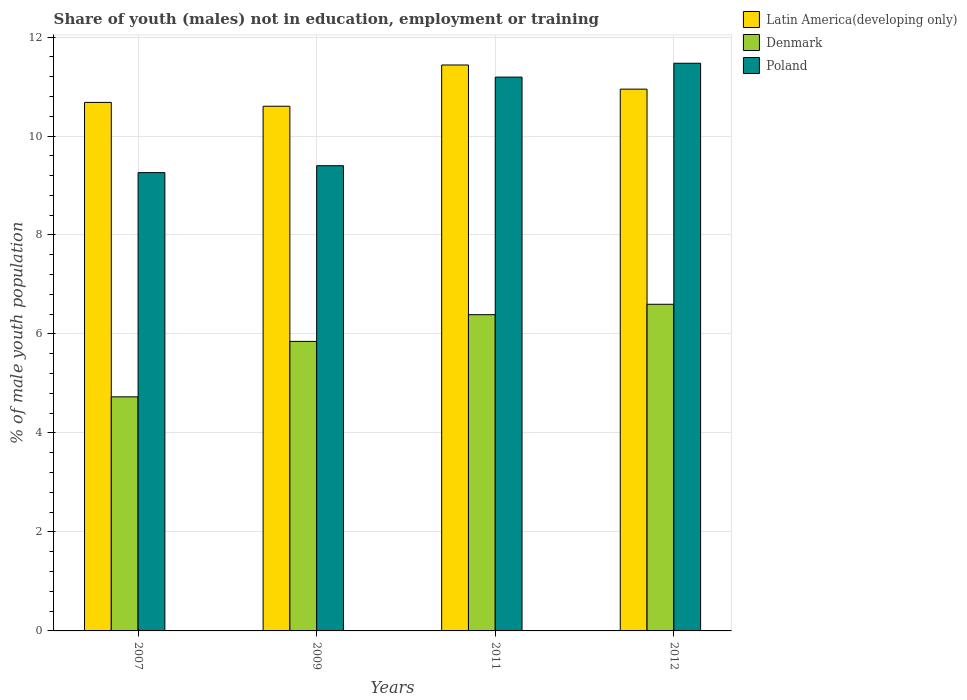How many different coloured bars are there?
Your response must be concise. 3. How many groups of bars are there?
Offer a very short reply. 4. Are the number of bars per tick equal to the number of legend labels?
Give a very brief answer. Yes. Are the number of bars on each tick of the X-axis equal?
Offer a very short reply. Yes. How many bars are there on the 3rd tick from the left?
Your answer should be very brief. 3. How many bars are there on the 4th tick from the right?
Your answer should be very brief. 3. What is the label of the 4th group of bars from the left?
Make the answer very short. 2012. What is the percentage of unemployed males population in in Latin America(developing only) in 2007?
Provide a succinct answer. 10.68. Across all years, what is the maximum percentage of unemployed males population in in Poland?
Your answer should be compact. 11.47. Across all years, what is the minimum percentage of unemployed males population in in Denmark?
Provide a short and direct response. 4.73. In which year was the percentage of unemployed males population in in Latin America(developing only) maximum?
Your response must be concise. 2011. In which year was the percentage of unemployed males population in in Denmark minimum?
Offer a very short reply. 2007. What is the total percentage of unemployed males population in in Denmark in the graph?
Keep it short and to the point. 23.57. What is the difference between the percentage of unemployed males population in in Latin America(developing only) in 2011 and that in 2012?
Offer a very short reply. 0.49. What is the difference between the percentage of unemployed males population in in Denmark in 2011 and the percentage of unemployed males population in in Latin America(developing only) in 2009?
Your answer should be compact. -4.21. What is the average percentage of unemployed males population in in Poland per year?
Your answer should be very brief. 10.33. In the year 2009, what is the difference between the percentage of unemployed males population in in Denmark and percentage of unemployed males population in in Poland?
Your response must be concise. -3.55. In how many years, is the percentage of unemployed males population in in Denmark greater than 10.4 %?
Give a very brief answer. 0. What is the ratio of the percentage of unemployed males population in in Poland in 2009 to that in 2012?
Your answer should be compact. 0.82. Is the difference between the percentage of unemployed males population in in Denmark in 2011 and 2012 greater than the difference between the percentage of unemployed males population in in Poland in 2011 and 2012?
Make the answer very short. Yes. What is the difference between the highest and the second highest percentage of unemployed males population in in Poland?
Your answer should be compact. 0.28. What is the difference between the highest and the lowest percentage of unemployed males population in in Latin America(developing only)?
Provide a succinct answer. 0.83. Is the sum of the percentage of unemployed males population in in Latin America(developing only) in 2011 and 2012 greater than the maximum percentage of unemployed males population in in Poland across all years?
Provide a short and direct response. Yes. What does the 3rd bar from the left in 2009 represents?
Provide a succinct answer. Poland. What does the 3rd bar from the right in 2007 represents?
Offer a very short reply. Latin America(developing only). How many bars are there?
Offer a very short reply. 12. How many years are there in the graph?
Provide a succinct answer. 4. How many legend labels are there?
Provide a short and direct response. 3. What is the title of the graph?
Your answer should be very brief. Share of youth (males) not in education, employment or training. Does "Uruguay" appear as one of the legend labels in the graph?
Your answer should be very brief. No. What is the label or title of the Y-axis?
Make the answer very short. % of male youth population. What is the % of male youth population in Latin America(developing only) in 2007?
Offer a terse response. 10.68. What is the % of male youth population in Denmark in 2007?
Your response must be concise. 4.73. What is the % of male youth population in Poland in 2007?
Keep it short and to the point. 9.26. What is the % of male youth population in Latin America(developing only) in 2009?
Your answer should be compact. 10.6. What is the % of male youth population of Denmark in 2009?
Keep it short and to the point. 5.85. What is the % of male youth population of Poland in 2009?
Your response must be concise. 9.4. What is the % of male youth population in Latin America(developing only) in 2011?
Make the answer very short. 11.43. What is the % of male youth population of Denmark in 2011?
Make the answer very short. 6.39. What is the % of male youth population of Poland in 2011?
Offer a terse response. 11.19. What is the % of male youth population in Latin America(developing only) in 2012?
Your answer should be very brief. 10.95. What is the % of male youth population in Denmark in 2012?
Your answer should be very brief. 6.6. What is the % of male youth population of Poland in 2012?
Offer a terse response. 11.47. Across all years, what is the maximum % of male youth population of Latin America(developing only)?
Keep it short and to the point. 11.43. Across all years, what is the maximum % of male youth population of Denmark?
Make the answer very short. 6.6. Across all years, what is the maximum % of male youth population in Poland?
Your answer should be compact. 11.47. Across all years, what is the minimum % of male youth population in Latin America(developing only)?
Your answer should be compact. 10.6. Across all years, what is the minimum % of male youth population of Denmark?
Provide a succinct answer. 4.73. Across all years, what is the minimum % of male youth population in Poland?
Provide a short and direct response. 9.26. What is the total % of male youth population in Latin America(developing only) in the graph?
Give a very brief answer. 43.66. What is the total % of male youth population in Denmark in the graph?
Give a very brief answer. 23.57. What is the total % of male youth population of Poland in the graph?
Your answer should be very brief. 41.32. What is the difference between the % of male youth population of Latin America(developing only) in 2007 and that in 2009?
Offer a very short reply. 0.08. What is the difference between the % of male youth population in Denmark in 2007 and that in 2009?
Provide a succinct answer. -1.12. What is the difference between the % of male youth population of Poland in 2007 and that in 2009?
Make the answer very short. -0.14. What is the difference between the % of male youth population of Latin America(developing only) in 2007 and that in 2011?
Provide a succinct answer. -0.76. What is the difference between the % of male youth population of Denmark in 2007 and that in 2011?
Your answer should be compact. -1.66. What is the difference between the % of male youth population in Poland in 2007 and that in 2011?
Keep it short and to the point. -1.93. What is the difference between the % of male youth population in Latin America(developing only) in 2007 and that in 2012?
Keep it short and to the point. -0.27. What is the difference between the % of male youth population of Denmark in 2007 and that in 2012?
Offer a terse response. -1.87. What is the difference between the % of male youth population in Poland in 2007 and that in 2012?
Keep it short and to the point. -2.21. What is the difference between the % of male youth population of Latin America(developing only) in 2009 and that in 2011?
Your answer should be compact. -0.83. What is the difference between the % of male youth population of Denmark in 2009 and that in 2011?
Provide a succinct answer. -0.54. What is the difference between the % of male youth population in Poland in 2009 and that in 2011?
Offer a very short reply. -1.79. What is the difference between the % of male youth population of Latin America(developing only) in 2009 and that in 2012?
Offer a very short reply. -0.35. What is the difference between the % of male youth population in Denmark in 2009 and that in 2012?
Your answer should be compact. -0.75. What is the difference between the % of male youth population of Poland in 2009 and that in 2012?
Give a very brief answer. -2.07. What is the difference between the % of male youth population of Latin America(developing only) in 2011 and that in 2012?
Give a very brief answer. 0.49. What is the difference between the % of male youth population in Denmark in 2011 and that in 2012?
Keep it short and to the point. -0.21. What is the difference between the % of male youth population of Poland in 2011 and that in 2012?
Provide a succinct answer. -0.28. What is the difference between the % of male youth population of Latin America(developing only) in 2007 and the % of male youth population of Denmark in 2009?
Provide a succinct answer. 4.83. What is the difference between the % of male youth population of Latin America(developing only) in 2007 and the % of male youth population of Poland in 2009?
Ensure brevity in your answer.  1.28. What is the difference between the % of male youth population of Denmark in 2007 and the % of male youth population of Poland in 2009?
Your answer should be very brief. -4.67. What is the difference between the % of male youth population of Latin America(developing only) in 2007 and the % of male youth population of Denmark in 2011?
Make the answer very short. 4.29. What is the difference between the % of male youth population of Latin America(developing only) in 2007 and the % of male youth population of Poland in 2011?
Offer a terse response. -0.51. What is the difference between the % of male youth population of Denmark in 2007 and the % of male youth population of Poland in 2011?
Ensure brevity in your answer.  -6.46. What is the difference between the % of male youth population in Latin America(developing only) in 2007 and the % of male youth population in Denmark in 2012?
Make the answer very short. 4.08. What is the difference between the % of male youth population in Latin America(developing only) in 2007 and the % of male youth population in Poland in 2012?
Make the answer very short. -0.79. What is the difference between the % of male youth population of Denmark in 2007 and the % of male youth population of Poland in 2012?
Ensure brevity in your answer.  -6.74. What is the difference between the % of male youth population in Latin America(developing only) in 2009 and the % of male youth population in Denmark in 2011?
Provide a succinct answer. 4.21. What is the difference between the % of male youth population in Latin America(developing only) in 2009 and the % of male youth population in Poland in 2011?
Ensure brevity in your answer.  -0.59. What is the difference between the % of male youth population of Denmark in 2009 and the % of male youth population of Poland in 2011?
Provide a succinct answer. -5.34. What is the difference between the % of male youth population in Latin America(developing only) in 2009 and the % of male youth population in Denmark in 2012?
Offer a terse response. 4. What is the difference between the % of male youth population of Latin America(developing only) in 2009 and the % of male youth population of Poland in 2012?
Keep it short and to the point. -0.87. What is the difference between the % of male youth population in Denmark in 2009 and the % of male youth population in Poland in 2012?
Keep it short and to the point. -5.62. What is the difference between the % of male youth population in Latin America(developing only) in 2011 and the % of male youth population in Denmark in 2012?
Offer a very short reply. 4.83. What is the difference between the % of male youth population of Latin America(developing only) in 2011 and the % of male youth population of Poland in 2012?
Give a very brief answer. -0.04. What is the difference between the % of male youth population in Denmark in 2011 and the % of male youth population in Poland in 2012?
Keep it short and to the point. -5.08. What is the average % of male youth population of Latin America(developing only) per year?
Provide a succinct answer. 10.92. What is the average % of male youth population in Denmark per year?
Keep it short and to the point. 5.89. What is the average % of male youth population of Poland per year?
Your answer should be compact. 10.33. In the year 2007, what is the difference between the % of male youth population in Latin America(developing only) and % of male youth population in Denmark?
Offer a very short reply. 5.95. In the year 2007, what is the difference between the % of male youth population in Latin America(developing only) and % of male youth population in Poland?
Give a very brief answer. 1.42. In the year 2007, what is the difference between the % of male youth population in Denmark and % of male youth population in Poland?
Your answer should be compact. -4.53. In the year 2009, what is the difference between the % of male youth population of Latin America(developing only) and % of male youth population of Denmark?
Your response must be concise. 4.75. In the year 2009, what is the difference between the % of male youth population in Latin America(developing only) and % of male youth population in Poland?
Your answer should be very brief. 1.2. In the year 2009, what is the difference between the % of male youth population in Denmark and % of male youth population in Poland?
Your answer should be very brief. -3.55. In the year 2011, what is the difference between the % of male youth population in Latin America(developing only) and % of male youth population in Denmark?
Make the answer very short. 5.04. In the year 2011, what is the difference between the % of male youth population in Latin America(developing only) and % of male youth population in Poland?
Provide a short and direct response. 0.24. In the year 2012, what is the difference between the % of male youth population of Latin America(developing only) and % of male youth population of Denmark?
Provide a short and direct response. 4.35. In the year 2012, what is the difference between the % of male youth population in Latin America(developing only) and % of male youth population in Poland?
Your answer should be compact. -0.52. In the year 2012, what is the difference between the % of male youth population of Denmark and % of male youth population of Poland?
Offer a terse response. -4.87. What is the ratio of the % of male youth population in Latin America(developing only) in 2007 to that in 2009?
Make the answer very short. 1.01. What is the ratio of the % of male youth population in Denmark in 2007 to that in 2009?
Provide a succinct answer. 0.81. What is the ratio of the % of male youth population of Poland in 2007 to that in 2009?
Your response must be concise. 0.99. What is the ratio of the % of male youth population in Latin America(developing only) in 2007 to that in 2011?
Give a very brief answer. 0.93. What is the ratio of the % of male youth population in Denmark in 2007 to that in 2011?
Offer a very short reply. 0.74. What is the ratio of the % of male youth population in Poland in 2007 to that in 2011?
Provide a short and direct response. 0.83. What is the ratio of the % of male youth population of Latin America(developing only) in 2007 to that in 2012?
Keep it short and to the point. 0.98. What is the ratio of the % of male youth population in Denmark in 2007 to that in 2012?
Ensure brevity in your answer.  0.72. What is the ratio of the % of male youth population in Poland in 2007 to that in 2012?
Keep it short and to the point. 0.81. What is the ratio of the % of male youth population in Latin America(developing only) in 2009 to that in 2011?
Provide a succinct answer. 0.93. What is the ratio of the % of male youth population in Denmark in 2009 to that in 2011?
Make the answer very short. 0.92. What is the ratio of the % of male youth population of Poland in 2009 to that in 2011?
Give a very brief answer. 0.84. What is the ratio of the % of male youth population of Latin America(developing only) in 2009 to that in 2012?
Make the answer very short. 0.97. What is the ratio of the % of male youth population of Denmark in 2009 to that in 2012?
Your response must be concise. 0.89. What is the ratio of the % of male youth population of Poland in 2009 to that in 2012?
Your answer should be very brief. 0.82. What is the ratio of the % of male youth population of Latin America(developing only) in 2011 to that in 2012?
Your answer should be very brief. 1.04. What is the ratio of the % of male youth population in Denmark in 2011 to that in 2012?
Your answer should be compact. 0.97. What is the ratio of the % of male youth population of Poland in 2011 to that in 2012?
Offer a terse response. 0.98. What is the difference between the highest and the second highest % of male youth population in Latin America(developing only)?
Ensure brevity in your answer.  0.49. What is the difference between the highest and the second highest % of male youth population of Denmark?
Give a very brief answer. 0.21. What is the difference between the highest and the second highest % of male youth population in Poland?
Your answer should be compact. 0.28. What is the difference between the highest and the lowest % of male youth population of Latin America(developing only)?
Offer a terse response. 0.83. What is the difference between the highest and the lowest % of male youth population in Denmark?
Your answer should be compact. 1.87. What is the difference between the highest and the lowest % of male youth population of Poland?
Give a very brief answer. 2.21. 